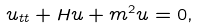Convert formula to latex. <formula><loc_0><loc_0><loc_500><loc_500>u _ { t t } + H u + m ^ { 2 } u = 0 ,</formula> 